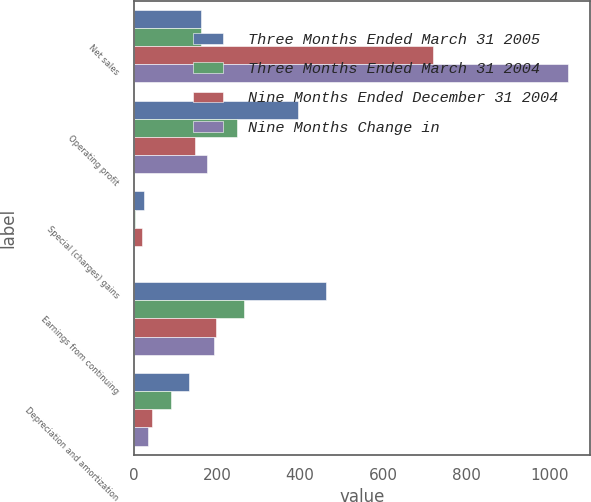Convert chart to OTSL. <chart><loc_0><loc_0><loc_500><loc_500><stacked_bar_chart><ecel><fcel>Net sales<fcel>Operating profit<fcel>Special (charges) gains<fcel>Earnings from continuing<fcel>Depreciation and amortization<nl><fcel>Three Months Ended March 31 2005<fcel>162.5<fcel>396<fcel>24<fcel>462<fcel>133<nl><fcel>Three Months Ended March 31 2004<fcel>162.5<fcel>248<fcel>3<fcel>265<fcel>89<nl><fcel>Nine Months Ended December 31 2004<fcel>719<fcel>148<fcel>21<fcel>197<fcel>44<nl><fcel>Nine Months Change in<fcel>1044<fcel>177<fcel>1<fcel>193<fcel>34<nl></chart> 